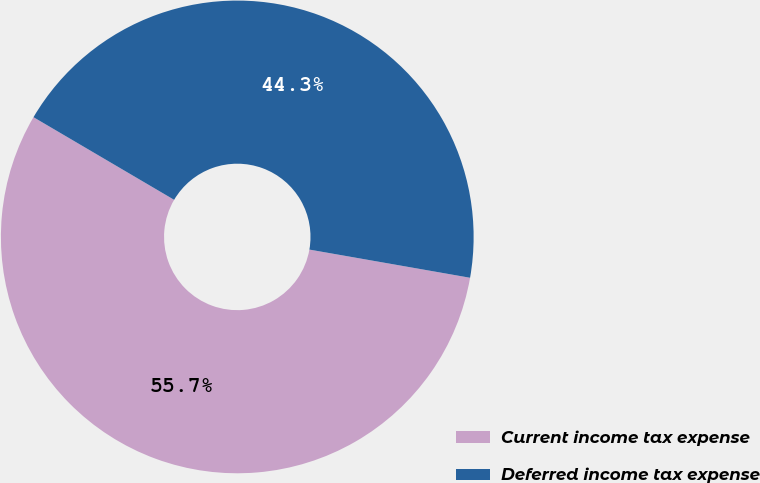Convert chart. <chart><loc_0><loc_0><loc_500><loc_500><pie_chart><fcel>Current income tax expense<fcel>Deferred income tax expense<nl><fcel>55.69%<fcel>44.31%<nl></chart> 